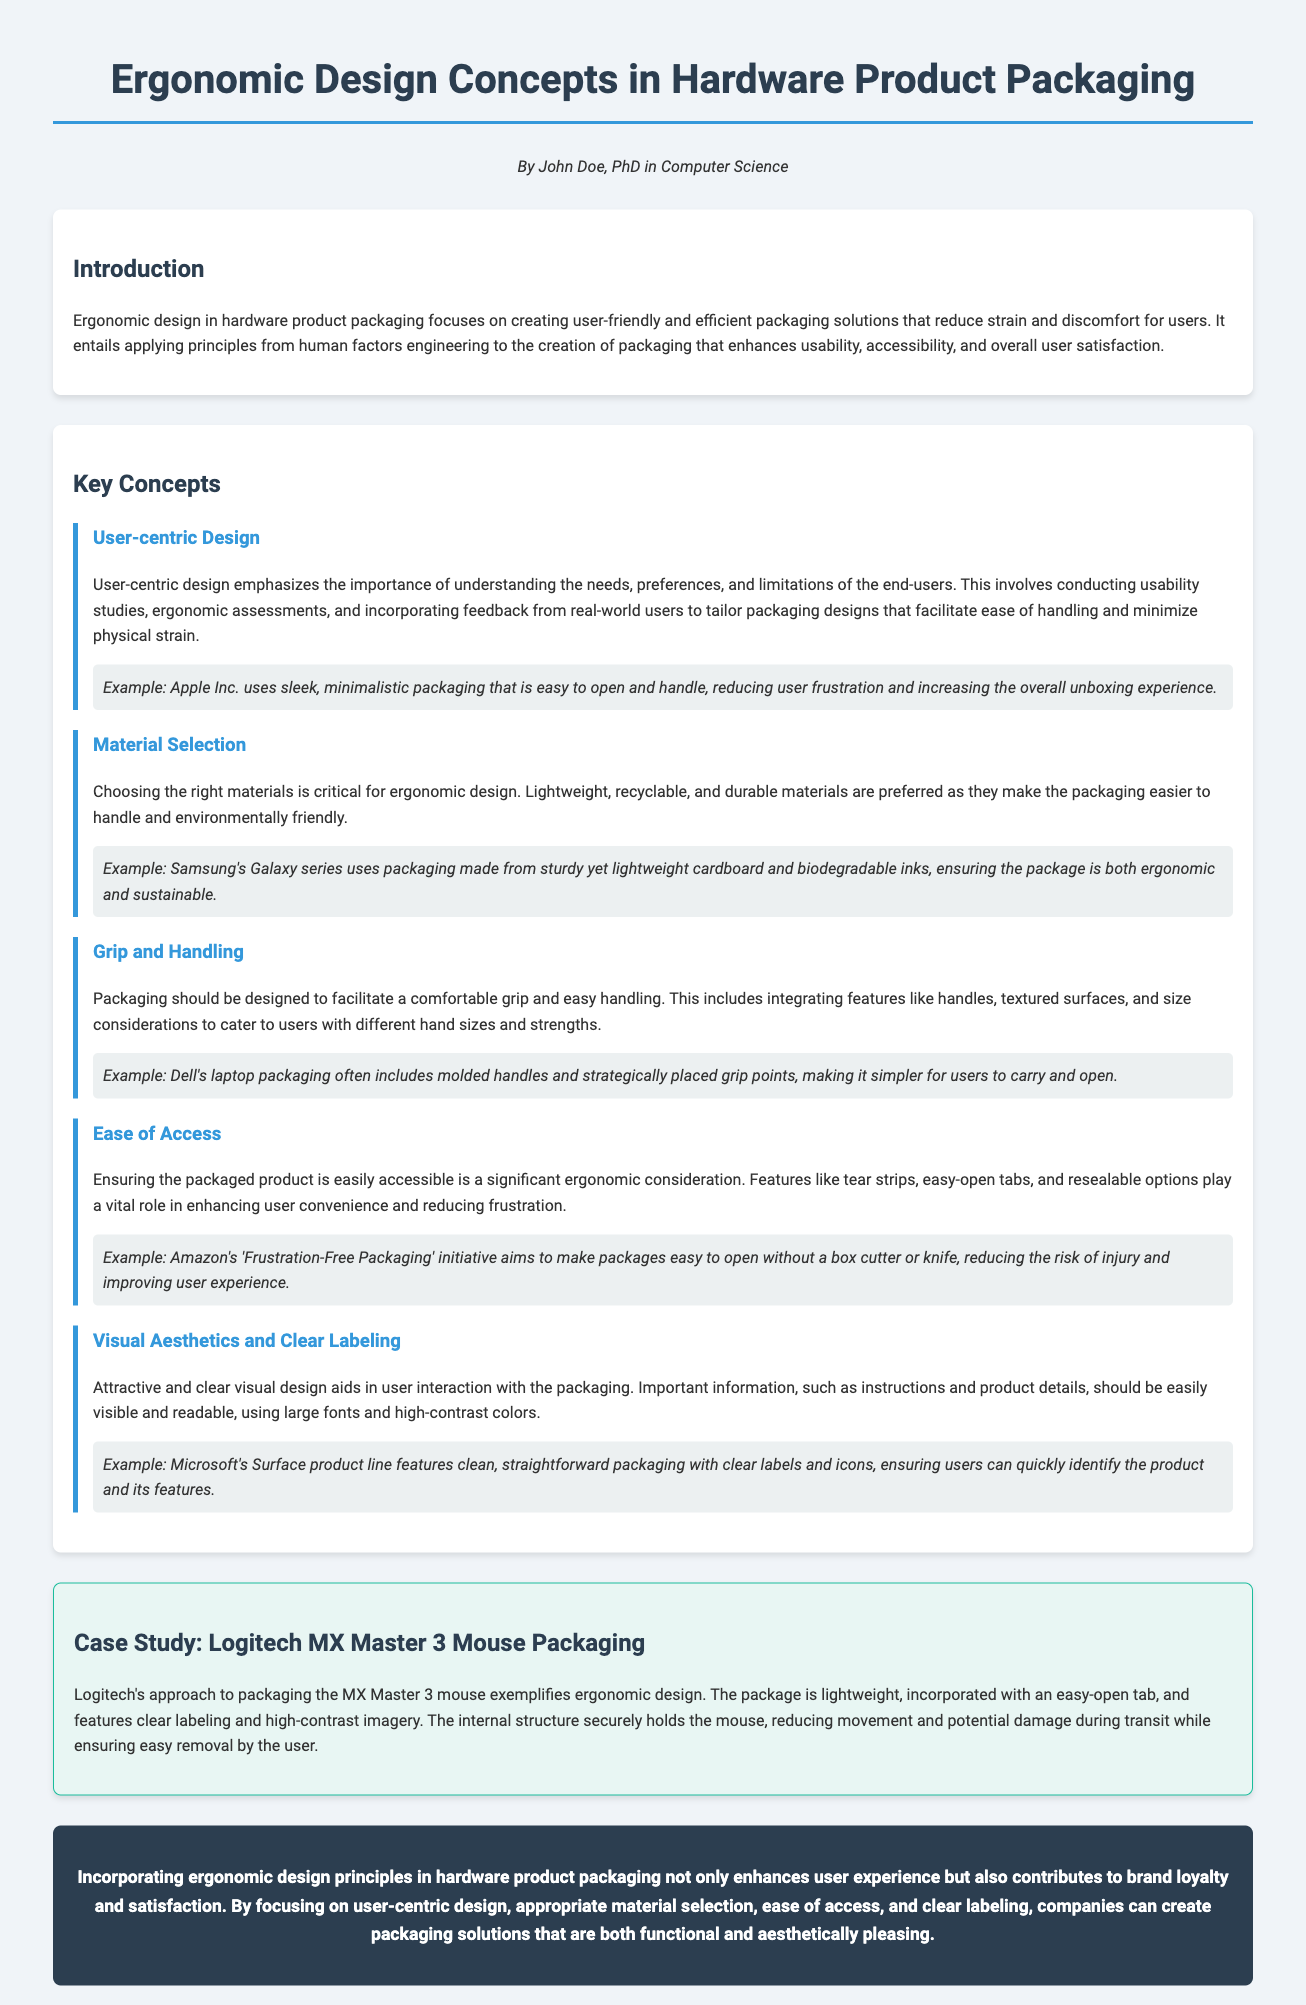What is the title of the document? The title of the document is mentioned at the top of the rendered page.
Answer: Ergonomic Design Concepts in Hardware Product Packaging Who is the author of the document? The author's name is provided in the author section under the title.
Answer: John Doe, PhD in Computer Science What does user-centric design emphasize? This information is found in the key concepts section focusing on user-centric design.
Answer: Understanding the needs, preferences, and limitations of the end-users Which example is provided for grip and handling? The example for grip and handling can be found under that specific concept.
Answer: Dell's laptop packaging What is a major focus of the 'Frustration-Free Packaging' initiative? This initiative is explained under the ease of access concept in the document.
Answer: Making packages easy to open What type of packaging does Logitech's MX Master 3 mouse exemplify? This information is highlighted in the case study section.
Answer: Ergonomic design What is the preferred characteristic of materials used in ergonomic packaging? Material selection is discussed, focusing on the preferred characteristics.
Answer: Lightweight, recyclable, and durable materials What is emphasized under visual aesthetics and clear labeling? This aspect is discussed in the visual aesthetics and clear labeling concept.
Answer: Important information should be easily visible and readable 